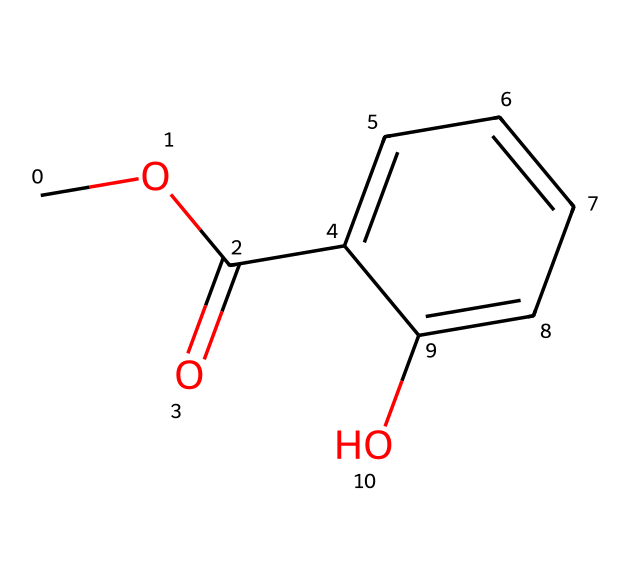What is the name of this chemical? The SMILES representation indicates that the chemical structure corresponds to methyl salicylate, which is known for its use in various applications, including as a solvent in cleaning solutions.
Answer: methyl salicylate How many carbon atoms are in methyl salicylate? By examining the SMILES notation, we can count the number of 'C' characters, which directly reflect the number of carbon atoms present in the molecule. There are 9 carbon atoms in total.
Answer: 9 What type of functional group is present in this structure? The structure includes an ester functional group, identified by the presence of a carbonyl (C=O) adjacent to an alkoxy group (CO). This functional grouping is characteristic of esters.
Answer: ester What is the molecular formula of methyl salicylate? By analyzing the elements indicated in the SMILES notation, we can determine that methyl salicylate contains 9 carbon atoms, 10 hydrogen atoms, and 3 oxygen atoms, leading to the molecular formula C9H10O3.
Answer: C9H10O3 What type of bond connects the carbonyl carbon to the oxygen in the ester group? In the ester functional group, the carbonyl carbon is double-bonded to an oxygen atom, which forms a carbon-oxygen double bond (C=O), a defining feature of esters.
Answer: double bond 